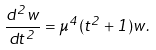<formula> <loc_0><loc_0><loc_500><loc_500>\frac { d ^ { 2 } w } { d t ^ { 2 } } = \mu ^ { 4 } ( t ^ { 2 } + 1 ) w .</formula> 